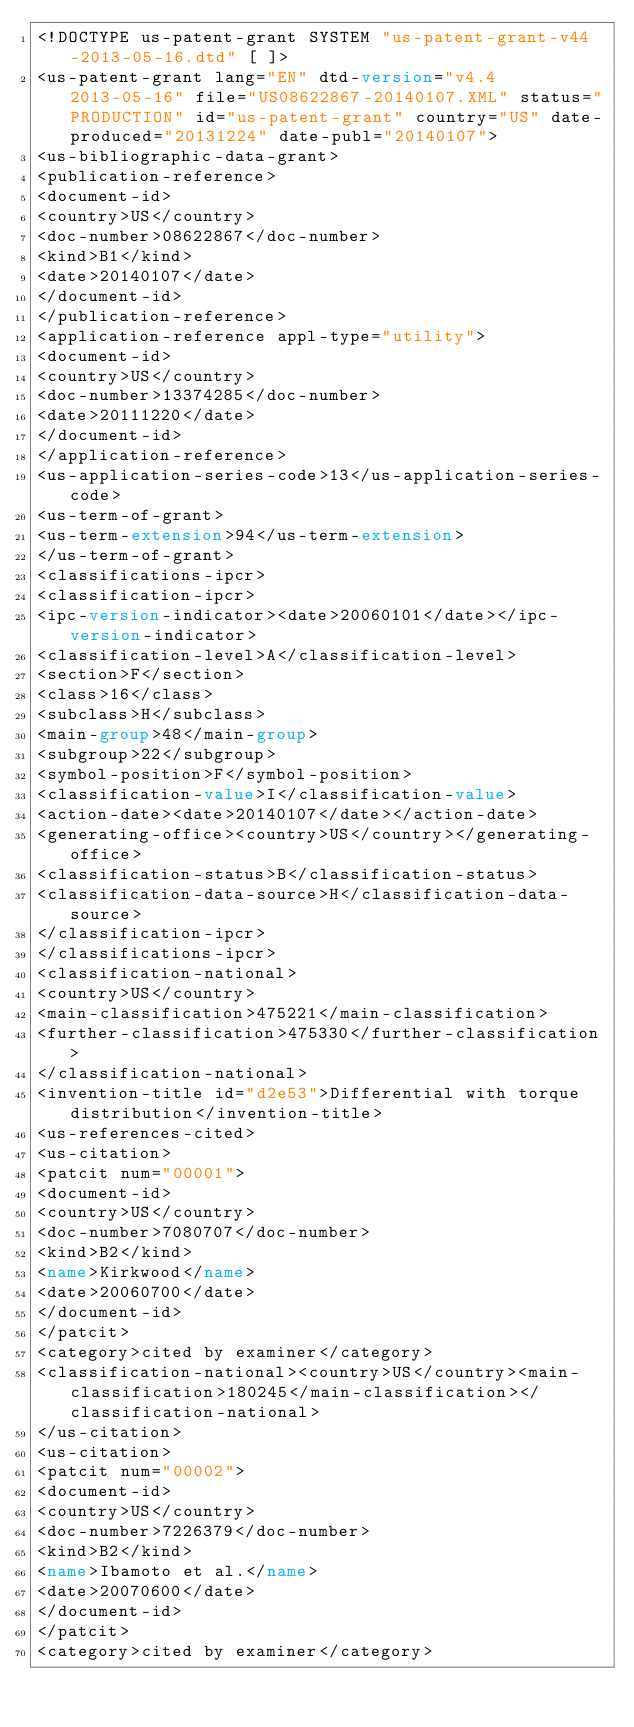Convert code to text. <code><loc_0><loc_0><loc_500><loc_500><_XML_><!DOCTYPE us-patent-grant SYSTEM "us-patent-grant-v44-2013-05-16.dtd" [ ]>
<us-patent-grant lang="EN" dtd-version="v4.4 2013-05-16" file="US08622867-20140107.XML" status="PRODUCTION" id="us-patent-grant" country="US" date-produced="20131224" date-publ="20140107">
<us-bibliographic-data-grant>
<publication-reference>
<document-id>
<country>US</country>
<doc-number>08622867</doc-number>
<kind>B1</kind>
<date>20140107</date>
</document-id>
</publication-reference>
<application-reference appl-type="utility">
<document-id>
<country>US</country>
<doc-number>13374285</doc-number>
<date>20111220</date>
</document-id>
</application-reference>
<us-application-series-code>13</us-application-series-code>
<us-term-of-grant>
<us-term-extension>94</us-term-extension>
</us-term-of-grant>
<classifications-ipcr>
<classification-ipcr>
<ipc-version-indicator><date>20060101</date></ipc-version-indicator>
<classification-level>A</classification-level>
<section>F</section>
<class>16</class>
<subclass>H</subclass>
<main-group>48</main-group>
<subgroup>22</subgroup>
<symbol-position>F</symbol-position>
<classification-value>I</classification-value>
<action-date><date>20140107</date></action-date>
<generating-office><country>US</country></generating-office>
<classification-status>B</classification-status>
<classification-data-source>H</classification-data-source>
</classification-ipcr>
</classifications-ipcr>
<classification-national>
<country>US</country>
<main-classification>475221</main-classification>
<further-classification>475330</further-classification>
</classification-national>
<invention-title id="d2e53">Differential with torque distribution</invention-title>
<us-references-cited>
<us-citation>
<patcit num="00001">
<document-id>
<country>US</country>
<doc-number>7080707</doc-number>
<kind>B2</kind>
<name>Kirkwood</name>
<date>20060700</date>
</document-id>
</patcit>
<category>cited by examiner</category>
<classification-national><country>US</country><main-classification>180245</main-classification></classification-national>
</us-citation>
<us-citation>
<patcit num="00002">
<document-id>
<country>US</country>
<doc-number>7226379</doc-number>
<kind>B2</kind>
<name>Ibamoto et al.</name>
<date>20070600</date>
</document-id>
</patcit>
<category>cited by examiner</category></code> 